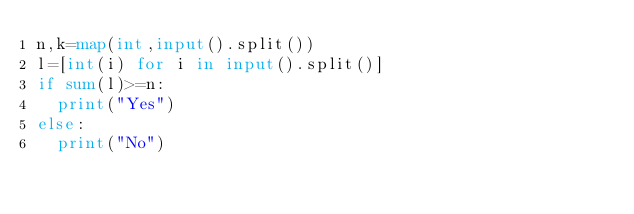Convert code to text. <code><loc_0><loc_0><loc_500><loc_500><_Python_>n,k=map(int,input().split())
l=[int(i) for i in input().split()]
if sum(l)>=n:
  print("Yes")
else:
  print("No")</code> 